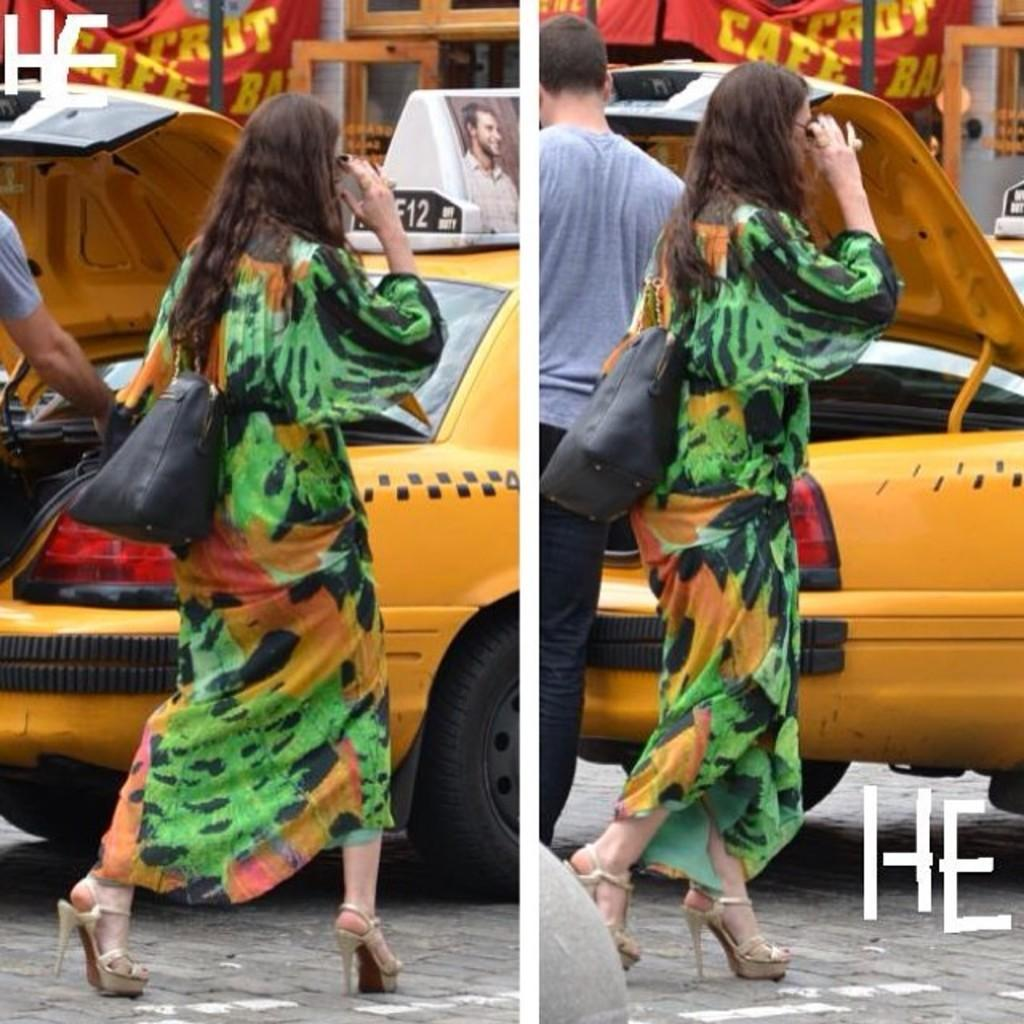<image>
Render a clear and concise summary of the photo. a lady walking with the word He on the bottom 